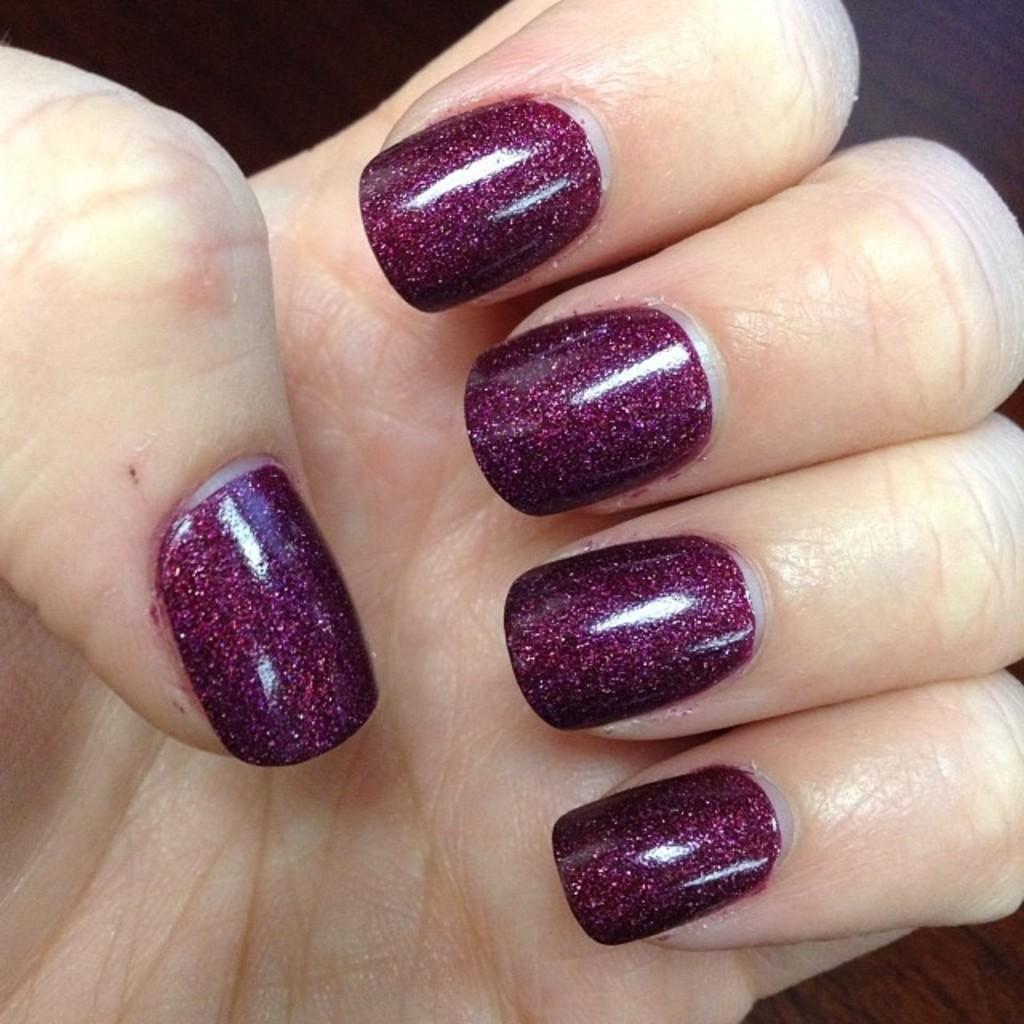What body part is visible in the image? There are fingers of a person in the image. What is applied to the nails of the fingers? Nail polish is visible on the fingers. How many babies are crawling on the ground in the image? There are no babies present in the image; it only shows fingers with nail polish. 